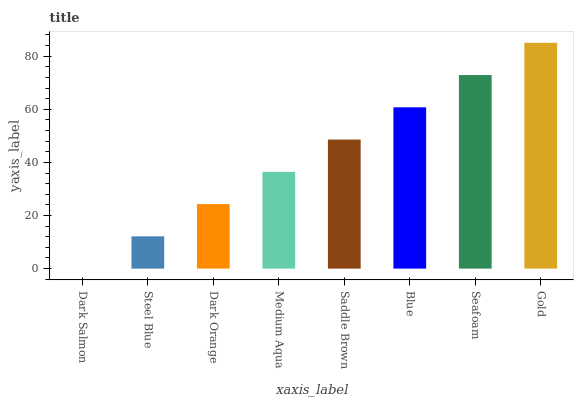Is Steel Blue the minimum?
Answer yes or no. No. Is Steel Blue the maximum?
Answer yes or no. No. Is Steel Blue greater than Dark Salmon?
Answer yes or no. Yes. Is Dark Salmon less than Steel Blue?
Answer yes or no. Yes. Is Dark Salmon greater than Steel Blue?
Answer yes or no. No. Is Steel Blue less than Dark Salmon?
Answer yes or no. No. Is Saddle Brown the high median?
Answer yes or no. Yes. Is Medium Aqua the low median?
Answer yes or no. Yes. Is Dark Orange the high median?
Answer yes or no. No. Is Dark Salmon the low median?
Answer yes or no. No. 